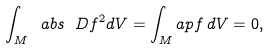<formula> <loc_0><loc_0><loc_500><loc_500>\int _ { M } \ a b s { \ D f } ^ { 2 } d V = \int _ { M } \L a p f \, d V = 0 ,</formula> 